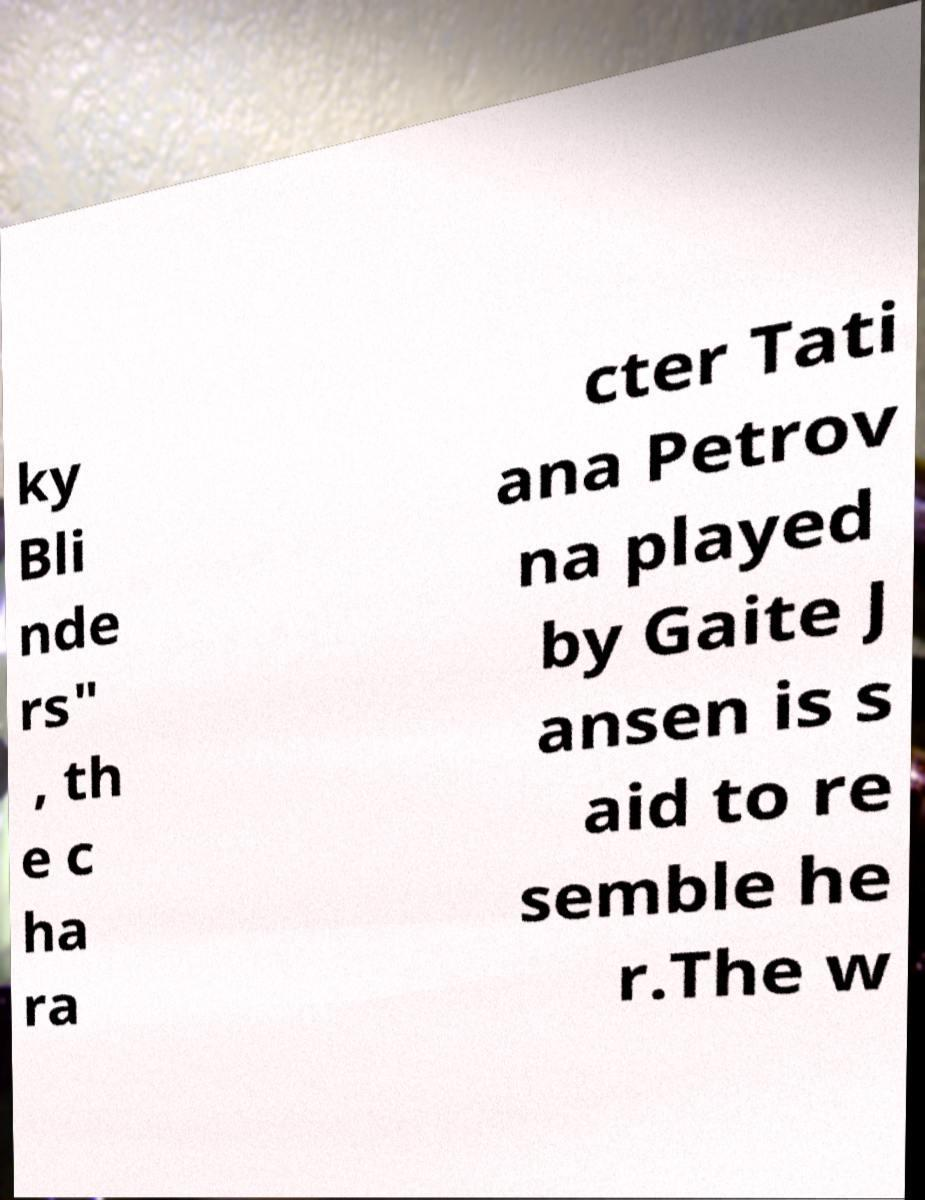There's text embedded in this image that I need extracted. Can you transcribe it verbatim? ky Bli nde rs" , th e c ha ra cter Tati ana Petrov na played by Gaite J ansen is s aid to re semble he r.The w 